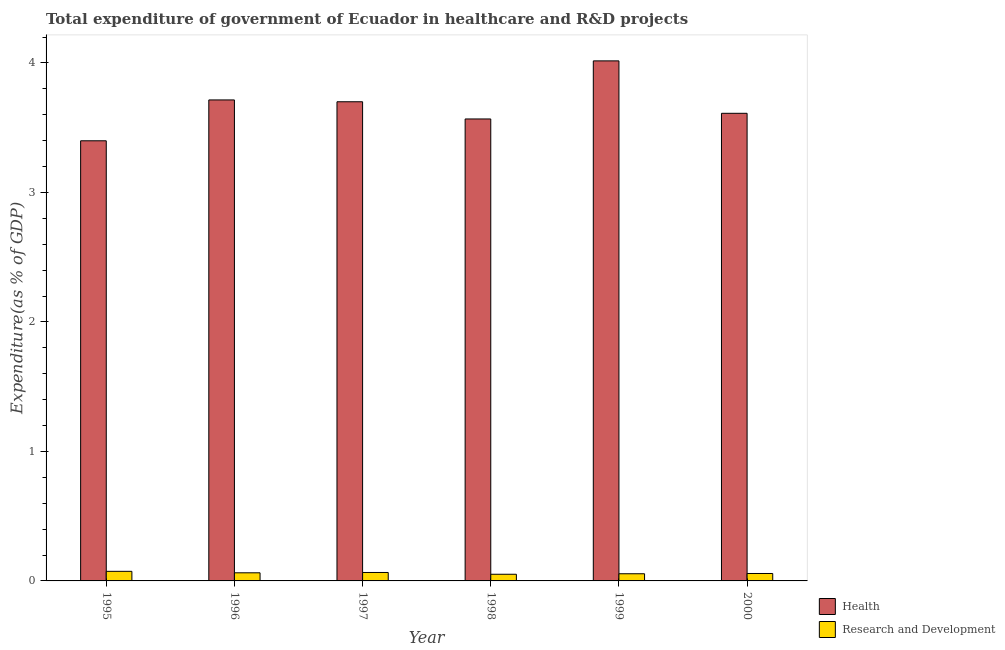How many different coloured bars are there?
Provide a short and direct response. 2. What is the expenditure in healthcare in 1999?
Make the answer very short. 4.02. Across all years, what is the maximum expenditure in r&d?
Keep it short and to the point. 0.07. Across all years, what is the minimum expenditure in healthcare?
Provide a succinct answer. 3.4. In which year was the expenditure in r&d maximum?
Give a very brief answer. 1995. What is the total expenditure in healthcare in the graph?
Ensure brevity in your answer.  22.01. What is the difference between the expenditure in healthcare in 1995 and that in 1997?
Make the answer very short. -0.3. What is the difference between the expenditure in r&d in 1996 and the expenditure in healthcare in 1999?
Offer a very short reply. 0.01. What is the average expenditure in healthcare per year?
Provide a short and direct response. 3.67. In the year 1996, what is the difference between the expenditure in healthcare and expenditure in r&d?
Ensure brevity in your answer.  0. In how many years, is the expenditure in healthcare greater than 0.6000000000000001 %?
Provide a short and direct response. 6. What is the ratio of the expenditure in healthcare in 1996 to that in 1998?
Offer a very short reply. 1.04. Is the expenditure in healthcare in 1995 less than that in 1997?
Ensure brevity in your answer.  Yes. What is the difference between the highest and the second highest expenditure in healthcare?
Offer a terse response. 0.3. What is the difference between the highest and the lowest expenditure in healthcare?
Offer a terse response. 0.62. What does the 2nd bar from the left in 1996 represents?
Your answer should be very brief. Research and Development. What does the 2nd bar from the right in 1995 represents?
Provide a succinct answer. Health. How many bars are there?
Provide a succinct answer. 12. Where does the legend appear in the graph?
Give a very brief answer. Bottom right. How are the legend labels stacked?
Offer a very short reply. Vertical. What is the title of the graph?
Offer a very short reply. Total expenditure of government of Ecuador in healthcare and R&D projects. What is the label or title of the X-axis?
Keep it short and to the point. Year. What is the label or title of the Y-axis?
Make the answer very short. Expenditure(as % of GDP). What is the Expenditure(as % of GDP) of Health in 1995?
Offer a very short reply. 3.4. What is the Expenditure(as % of GDP) of Research and Development in 1995?
Provide a short and direct response. 0.07. What is the Expenditure(as % of GDP) in Health in 1996?
Offer a very short reply. 3.71. What is the Expenditure(as % of GDP) of Research and Development in 1996?
Make the answer very short. 0.06. What is the Expenditure(as % of GDP) of Health in 1997?
Provide a succinct answer. 3.7. What is the Expenditure(as % of GDP) in Research and Development in 1997?
Make the answer very short. 0.07. What is the Expenditure(as % of GDP) of Health in 1998?
Provide a short and direct response. 3.57. What is the Expenditure(as % of GDP) in Research and Development in 1998?
Keep it short and to the point. 0.05. What is the Expenditure(as % of GDP) of Health in 1999?
Offer a terse response. 4.02. What is the Expenditure(as % of GDP) of Research and Development in 1999?
Provide a short and direct response. 0.06. What is the Expenditure(as % of GDP) of Health in 2000?
Keep it short and to the point. 3.61. What is the Expenditure(as % of GDP) of Research and Development in 2000?
Provide a succinct answer. 0.06. Across all years, what is the maximum Expenditure(as % of GDP) of Health?
Ensure brevity in your answer.  4.02. Across all years, what is the maximum Expenditure(as % of GDP) in Research and Development?
Offer a terse response. 0.07. Across all years, what is the minimum Expenditure(as % of GDP) of Health?
Keep it short and to the point. 3.4. Across all years, what is the minimum Expenditure(as % of GDP) in Research and Development?
Give a very brief answer. 0.05. What is the total Expenditure(as % of GDP) in Health in the graph?
Give a very brief answer. 22.01. What is the total Expenditure(as % of GDP) of Research and Development in the graph?
Give a very brief answer. 0.37. What is the difference between the Expenditure(as % of GDP) in Health in 1995 and that in 1996?
Provide a short and direct response. -0.32. What is the difference between the Expenditure(as % of GDP) in Research and Development in 1995 and that in 1996?
Your response must be concise. 0.01. What is the difference between the Expenditure(as % of GDP) in Health in 1995 and that in 1997?
Give a very brief answer. -0.3. What is the difference between the Expenditure(as % of GDP) of Research and Development in 1995 and that in 1997?
Ensure brevity in your answer.  0.01. What is the difference between the Expenditure(as % of GDP) of Health in 1995 and that in 1998?
Your answer should be very brief. -0.17. What is the difference between the Expenditure(as % of GDP) in Research and Development in 1995 and that in 1998?
Offer a very short reply. 0.02. What is the difference between the Expenditure(as % of GDP) in Health in 1995 and that in 1999?
Ensure brevity in your answer.  -0.62. What is the difference between the Expenditure(as % of GDP) of Research and Development in 1995 and that in 1999?
Ensure brevity in your answer.  0.02. What is the difference between the Expenditure(as % of GDP) of Health in 1995 and that in 2000?
Make the answer very short. -0.21. What is the difference between the Expenditure(as % of GDP) of Research and Development in 1995 and that in 2000?
Make the answer very short. 0.02. What is the difference between the Expenditure(as % of GDP) in Health in 1996 and that in 1997?
Your answer should be very brief. 0.01. What is the difference between the Expenditure(as % of GDP) in Research and Development in 1996 and that in 1997?
Give a very brief answer. -0. What is the difference between the Expenditure(as % of GDP) of Health in 1996 and that in 1998?
Your response must be concise. 0.15. What is the difference between the Expenditure(as % of GDP) of Research and Development in 1996 and that in 1998?
Offer a very short reply. 0.01. What is the difference between the Expenditure(as % of GDP) of Health in 1996 and that in 1999?
Provide a short and direct response. -0.3. What is the difference between the Expenditure(as % of GDP) in Research and Development in 1996 and that in 1999?
Your response must be concise. 0.01. What is the difference between the Expenditure(as % of GDP) of Health in 1996 and that in 2000?
Give a very brief answer. 0.1. What is the difference between the Expenditure(as % of GDP) of Research and Development in 1996 and that in 2000?
Your response must be concise. 0.01. What is the difference between the Expenditure(as % of GDP) in Health in 1997 and that in 1998?
Provide a succinct answer. 0.13. What is the difference between the Expenditure(as % of GDP) in Research and Development in 1997 and that in 1998?
Ensure brevity in your answer.  0.01. What is the difference between the Expenditure(as % of GDP) of Health in 1997 and that in 1999?
Keep it short and to the point. -0.32. What is the difference between the Expenditure(as % of GDP) in Research and Development in 1997 and that in 1999?
Make the answer very short. 0.01. What is the difference between the Expenditure(as % of GDP) of Health in 1997 and that in 2000?
Make the answer very short. 0.09. What is the difference between the Expenditure(as % of GDP) in Research and Development in 1997 and that in 2000?
Ensure brevity in your answer.  0.01. What is the difference between the Expenditure(as % of GDP) in Health in 1998 and that in 1999?
Make the answer very short. -0.45. What is the difference between the Expenditure(as % of GDP) in Research and Development in 1998 and that in 1999?
Keep it short and to the point. -0. What is the difference between the Expenditure(as % of GDP) in Health in 1998 and that in 2000?
Provide a succinct answer. -0.04. What is the difference between the Expenditure(as % of GDP) in Research and Development in 1998 and that in 2000?
Provide a short and direct response. -0.01. What is the difference between the Expenditure(as % of GDP) of Health in 1999 and that in 2000?
Your answer should be very brief. 0.4. What is the difference between the Expenditure(as % of GDP) of Research and Development in 1999 and that in 2000?
Ensure brevity in your answer.  -0. What is the difference between the Expenditure(as % of GDP) in Health in 1995 and the Expenditure(as % of GDP) in Research and Development in 1996?
Give a very brief answer. 3.34. What is the difference between the Expenditure(as % of GDP) in Health in 1995 and the Expenditure(as % of GDP) in Research and Development in 1997?
Your answer should be compact. 3.33. What is the difference between the Expenditure(as % of GDP) of Health in 1995 and the Expenditure(as % of GDP) of Research and Development in 1998?
Offer a very short reply. 3.35. What is the difference between the Expenditure(as % of GDP) in Health in 1995 and the Expenditure(as % of GDP) in Research and Development in 1999?
Provide a succinct answer. 3.34. What is the difference between the Expenditure(as % of GDP) in Health in 1995 and the Expenditure(as % of GDP) in Research and Development in 2000?
Ensure brevity in your answer.  3.34. What is the difference between the Expenditure(as % of GDP) of Health in 1996 and the Expenditure(as % of GDP) of Research and Development in 1997?
Make the answer very short. 3.65. What is the difference between the Expenditure(as % of GDP) of Health in 1996 and the Expenditure(as % of GDP) of Research and Development in 1998?
Provide a short and direct response. 3.66. What is the difference between the Expenditure(as % of GDP) of Health in 1996 and the Expenditure(as % of GDP) of Research and Development in 1999?
Your answer should be very brief. 3.66. What is the difference between the Expenditure(as % of GDP) in Health in 1996 and the Expenditure(as % of GDP) in Research and Development in 2000?
Offer a very short reply. 3.66. What is the difference between the Expenditure(as % of GDP) in Health in 1997 and the Expenditure(as % of GDP) in Research and Development in 1998?
Keep it short and to the point. 3.65. What is the difference between the Expenditure(as % of GDP) of Health in 1997 and the Expenditure(as % of GDP) of Research and Development in 1999?
Your answer should be compact. 3.64. What is the difference between the Expenditure(as % of GDP) in Health in 1997 and the Expenditure(as % of GDP) in Research and Development in 2000?
Offer a terse response. 3.64. What is the difference between the Expenditure(as % of GDP) of Health in 1998 and the Expenditure(as % of GDP) of Research and Development in 1999?
Make the answer very short. 3.51. What is the difference between the Expenditure(as % of GDP) in Health in 1998 and the Expenditure(as % of GDP) in Research and Development in 2000?
Your response must be concise. 3.51. What is the difference between the Expenditure(as % of GDP) of Health in 1999 and the Expenditure(as % of GDP) of Research and Development in 2000?
Ensure brevity in your answer.  3.96. What is the average Expenditure(as % of GDP) of Health per year?
Your answer should be very brief. 3.67. What is the average Expenditure(as % of GDP) of Research and Development per year?
Your answer should be very brief. 0.06. In the year 1995, what is the difference between the Expenditure(as % of GDP) in Health and Expenditure(as % of GDP) in Research and Development?
Ensure brevity in your answer.  3.32. In the year 1996, what is the difference between the Expenditure(as % of GDP) in Health and Expenditure(as % of GDP) in Research and Development?
Provide a succinct answer. 3.65. In the year 1997, what is the difference between the Expenditure(as % of GDP) in Health and Expenditure(as % of GDP) in Research and Development?
Make the answer very short. 3.63. In the year 1998, what is the difference between the Expenditure(as % of GDP) in Health and Expenditure(as % of GDP) in Research and Development?
Provide a short and direct response. 3.52. In the year 1999, what is the difference between the Expenditure(as % of GDP) in Health and Expenditure(as % of GDP) in Research and Development?
Offer a terse response. 3.96. In the year 2000, what is the difference between the Expenditure(as % of GDP) of Health and Expenditure(as % of GDP) of Research and Development?
Ensure brevity in your answer.  3.55. What is the ratio of the Expenditure(as % of GDP) of Health in 1995 to that in 1996?
Your response must be concise. 0.92. What is the ratio of the Expenditure(as % of GDP) of Research and Development in 1995 to that in 1996?
Provide a short and direct response. 1.18. What is the ratio of the Expenditure(as % of GDP) in Health in 1995 to that in 1997?
Your answer should be compact. 0.92. What is the ratio of the Expenditure(as % of GDP) of Research and Development in 1995 to that in 1997?
Make the answer very short. 1.14. What is the ratio of the Expenditure(as % of GDP) of Health in 1995 to that in 1998?
Offer a terse response. 0.95. What is the ratio of the Expenditure(as % of GDP) of Research and Development in 1995 to that in 1998?
Offer a very short reply. 1.44. What is the ratio of the Expenditure(as % of GDP) in Health in 1995 to that in 1999?
Give a very brief answer. 0.85. What is the ratio of the Expenditure(as % of GDP) of Research and Development in 1995 to that in 1999?
Your answer should be compact. 1.34. What is the ratio of the Expenditure(as % of GDP) of Research and Development in 1995 to that in 2000?
Your response must be concise. 1.29. What is the ratio of the Expenditure(as % of GDP) of Health in 1996 to that in 1997?
Your answer should be very brief. 1. What is the ratio of the Expenditure(as % of GDP) of Health in 1996 to that in 1998?
Your answer should be compact. 1.04. What is the ratio of the Expenditure(as % of GDP) of Research and Development in 1996 to that in 1998?
Your answer should be very brief. 1.22. What is the ratio of the Expenditure(as % of GDP) of Health in 1996 to that in 1999?
Give a very brief answer. 0.92. What is the ratio of the Expenditure(as % of GDP) of Research and Development in 1996 to that in 1999?
Make the answer very short. 1.13. What is the ratio of the Expenditure(as % of GDP) of Health in 1996 to that in 2000?
Provide a succinct answer. 1.03. What is the ratio of the Expenditure(as % of GDP) in Research and Development in 1996 to that in 2000?
Your answer should be compact. 1.09. What is the ratio of the Expenditure(as % of GDP) in Health in 1997 to that in 1998?
Give a very brief answer. 1.04. What is the ratio of the Expenditure(as % of GDP) of Research and Development in 1997 to that in 1998?
Provide a succinct answer. 1.27. What is the ratio of the Expenditure(as % of GDP) of Health in 1997 to that in 1999?
Provide a short and direct response. 0.92. What is the ratio of the Expenditure(as % of GDP) in Research and Development in 1997 to that in 1999?
Make the answer very short. 1.18. What is the ratio of the Expenditure(as % of GDP) in Health in 1997 to that in 2000?
Offer a very short reply. 1.02. What is the ratio of the Expenditure(as % of GDP) of Research and Development in 1997 to that in 2000?
Keep it short and to the point. 1.14. What is the ratio of the Expenditure(as % of GDP) in Health in 1998 to that in 1999?
Your answer should be compact. 0.89. What is the ratio of the Expenditure(as % of GDP) in Research and Development in 1998 to that in 1999?
Offer a terse response. 0.93. What is the ratio of the Expenditure(as % of GDP) in Health in 1998 to that in 2000?
Provide a succinct answer. 0.99. What is the ratio of the Expenditure(as % of GDP) of Research and Development in 1998 to that in 2000?
Give a very brief answer. 0.9. What is the ratio of the Expenditure(as % of GDP) in Health in 1999 to that in 2000?
Make the answer very short. 1.11. What is the difference between the highest and the second highest Expenditure(as % of GDP) of Health?
Offer a very short reply. 0.3. What is the difference between the highest and the second highest Expenditure(as % of GDP) in Research and Development?
Your response must be concise. 0.01. What is the difference between the highest and the lowest Expenditure(as % of GDP) in Health?
Your response must be concise. 0.62. What is the difference between the highest and the lowest Expenditure(as % of GDP) of Research and Development?
Give a very brief answer. 0.02. 